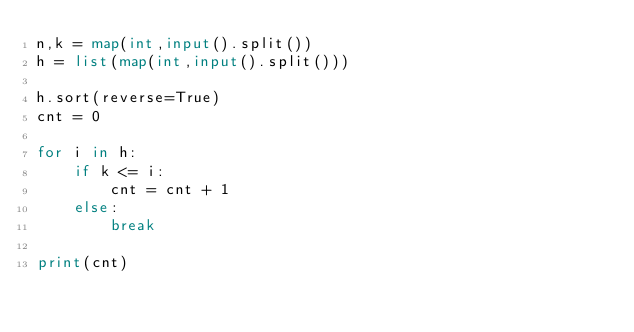Convert code to text. <code><loc_0><loc_0><loc_500><loc_500><_Python_>n,k = map(int,input().split())	
h = list(map(int,input().split()))

h.sort(reverse=True)
cnt = 0

for i in h:
    if k <= i:
        cnt = cnt + 1
    else:
        break

print(cnt)</code> 